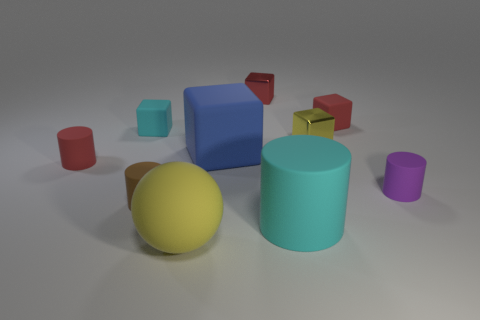Can you describe the lighting conditions in this image? The image displays a softly lit scene with uniform and diffused lighting. There are no harsh shadows or strong highlights, indicating an ambient light source, possibly simulating overcast daylight or indoor lighting provided by large, soft light panels. How does the lighting affect the perception of the objects? The diffuse lighting creates subtle shadows that help define the shapes of the objects without creating dark areas or overly bright spots. This gentle lighting condition allows for easier identification of object contours and color, providing a calm and balanced composition. 